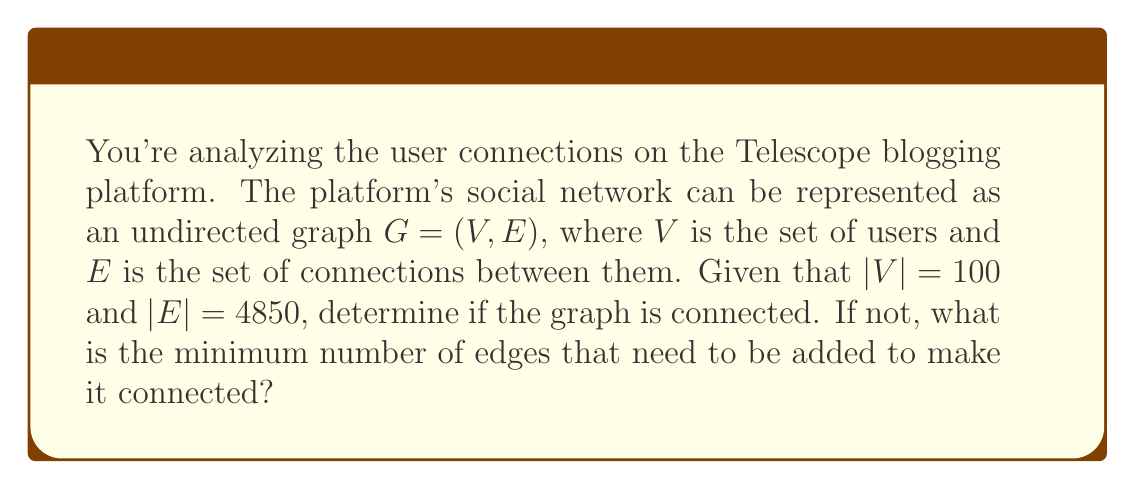Help me with this question. To solve this problem, we'll follow these steps:

1) First, recall that a graph is connected if there is a path between every pair of vertices.

2) For a graph with $n$ vertices to be connected, it must have at least $n-1$ edges. This forms a tree structure, which is the minimal connected graph.

3) However, having $n-1$ or more edges doesn't guarantee connectedness. We need to check if the number of edges is sufficient to potentially connect all vertices.

4) In a graph with $n$ vertices, the maximum number of edges is $\frac{n(n-1)}{2}$, which occurs in a complete graph where every vertex is connected to every other vertex.

5) In this case, $n = |V| = 100$. Let's calculate the maximum number of edges:

   $$\frac{n(n-1)}{2} = \frac{100(99)}{2} = 4950$$

6) The given graph has 4850 edges, which is very close to the maximum possible.

7) To determine the minimum number of edges needed for connectedness, we calculate $n-1$:

   $$100 - 1 = 99$$

8) Since 4850 > 99, the graph has more than enough edges to be connected.

9) In fact, with 4850 edges out of a possible 4950, it's extremely likely that the graph is connected. The probability of it not being connected is very small.

10) However, to be absolutely certain of connectedness, we would need to perform a graph traversal algorithm like Depth-First Search (DFS) or Breadth-First Search (BFS).

11) In the unlikely event that the graph is not connected, we would need to add at least one edge between any two disconnected components to make it connected.

Therefore, based on the high number of edges, we can conclude with high confidence that the graph is connected, and no additional edges are needed.
Answer: The graph is very likely connected, and no additional edges are needed. However, to be 100% certain, a graph traversal algorithm would need to be implemented. 